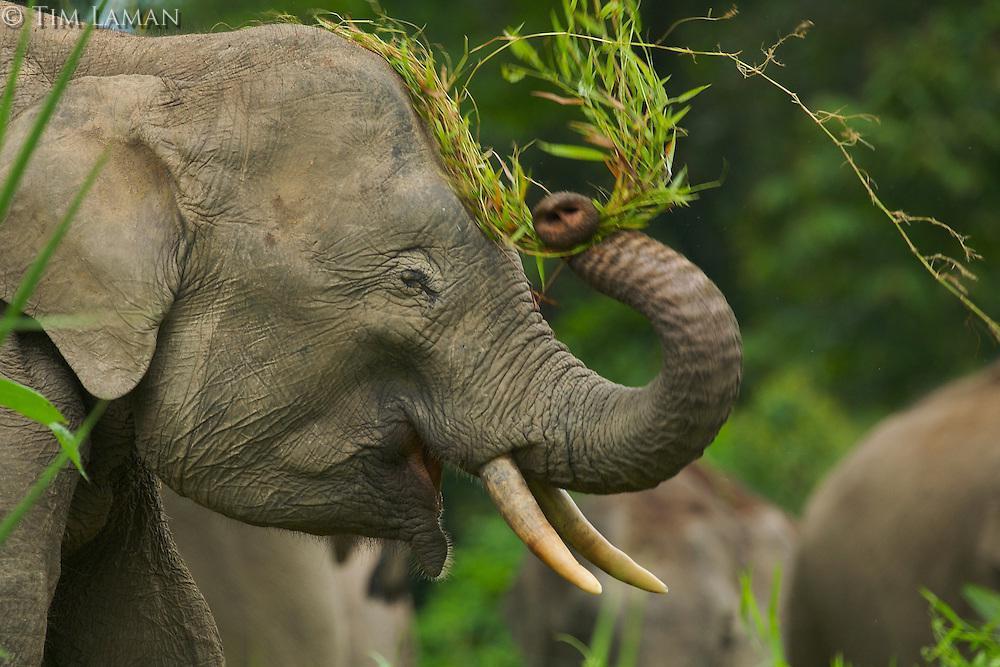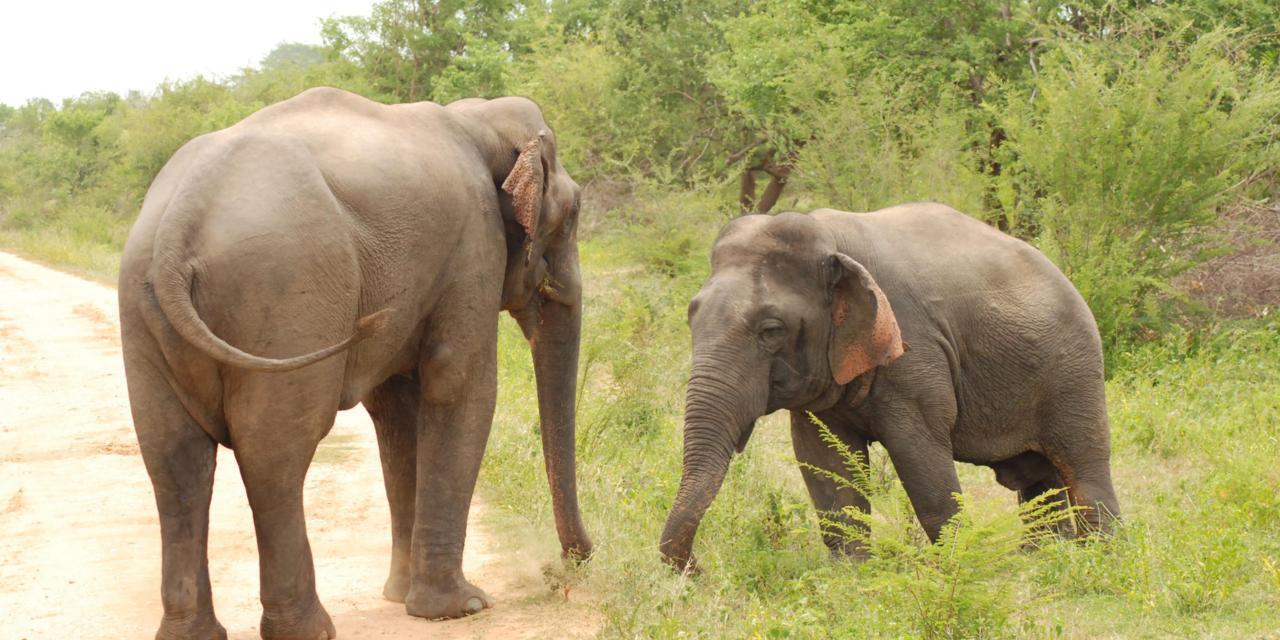The first image is the image on the left, the second image is the image on the right. For the images displayed, is the sentence "An image shows exactly two elephants, with at least one on a path with no greenery on it." factually correct? Answer yes or no. Yes. 